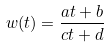<formula> <loc_0><loc_0><loc_500><loc_500>w ( t ) = \frac { a t + b } { c t + d }</formula> 